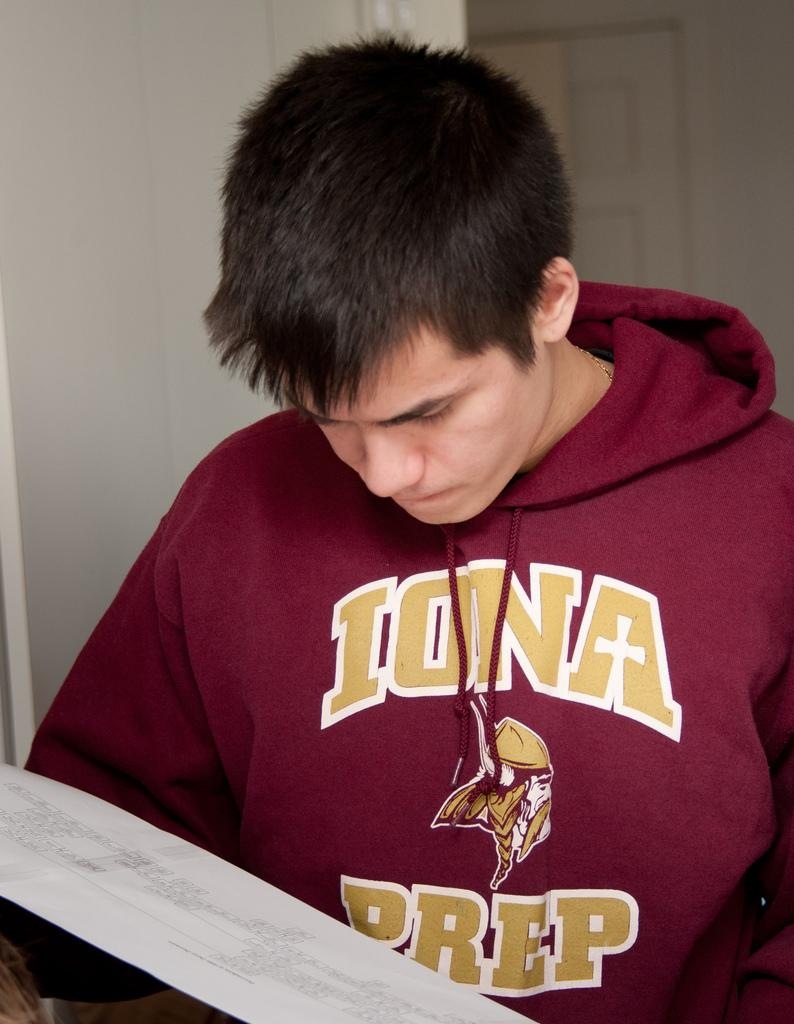<image>
Provide a brief description of the given image. A man reads a book while wearing a Iona Prep red sweatshirt. 